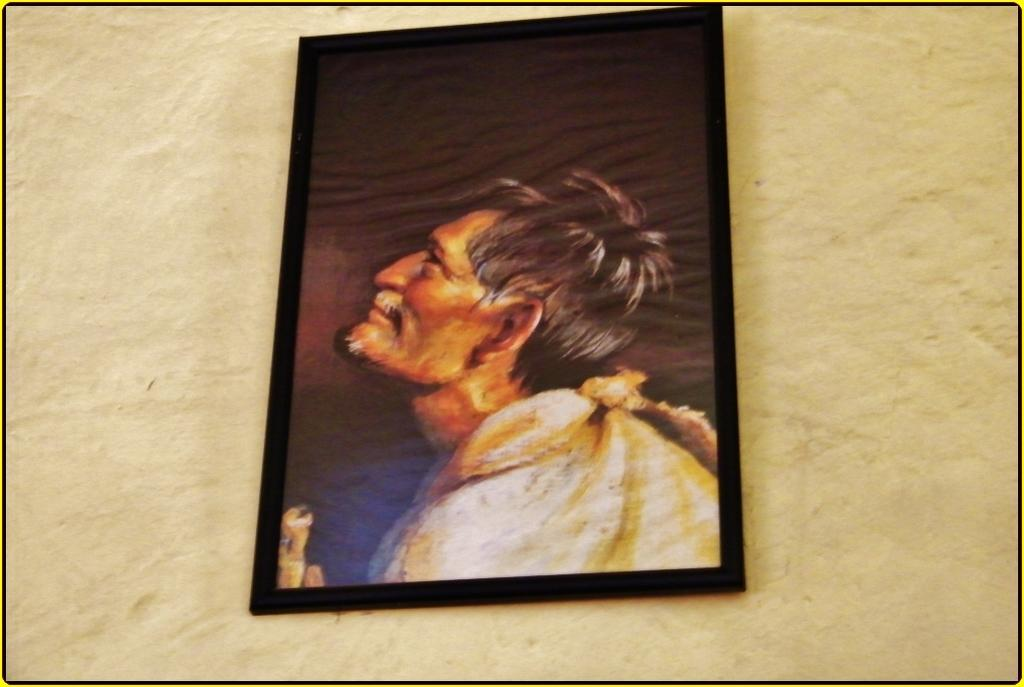What is the main object in the center of the image? There is a frame in the image, and it is located in the center. How is the frame positioned in the image? The frame is attached to the wall. What type of cracker is depicted inside the frame in the image? There is no cracker present inside the frame in the image. How does the chain connect to the frame in the image? There is no chain present in the image. 